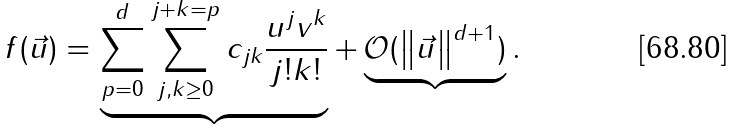Convert formula to latex. <formula><loc_0><loc_0><loc_500><loc_500>f ( \vec { u } ) = \underbrace { \sum _ { p = 0 } ^ { d } \sum _ { j , k \geq 0 } ^ { j + k = p } c _ { j k } \frac { u ^ { j } v ^ { k } } { j ! k ! } } + \underbrace { \mathcal { O } ( \left \| \vec { u } \right \| ^ { d + 1 } ) } .</formula> 